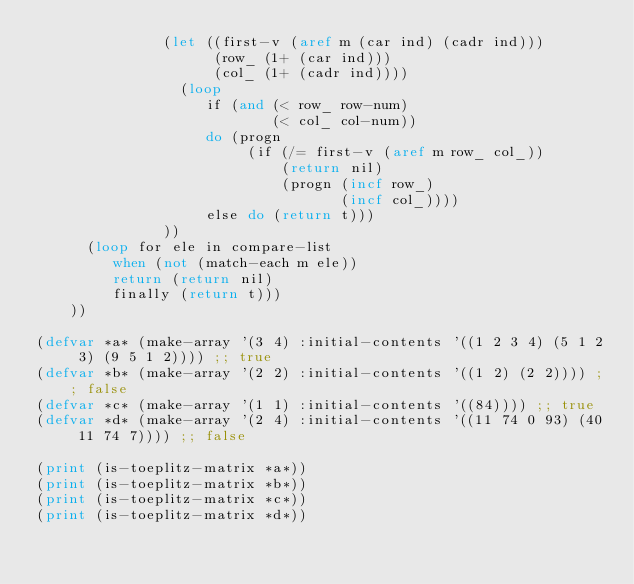<code> <loc_0><loc_0><loc_500><loc_500><_Lisp_>               (let ((first-v (aref m (car ind) (cadr ind)))
                     (row_ (1+ (car ind)))
                     (col_ (1+ (cadr ind))))
                 (loop
                    if (and (< row_ row-num)
                            (< col_ col-num))
                    do (progn 
                         (if (/= first-v (aref m row_ col_))
                             (return nil)
                             (progn (incf row_)
                                    (incf col_))))
                    else do (return t)))
               ))
      (loop for ele in compare-list
         when (not (match-each m ele))
         return (return nil)
         finally (return t)))
    ))

(defvar *a* (make-array '(3 4) :initial-contents '((1 2 3 4) (5 1 2 3) (9 5 1 2)))) ;; true
(defvar *b* (make-array '(2 2) :initial-contents '((1 2) (2 2)))) ;; false
(defvar *c* (make-array '(1 1) :initial-contents '((84)))) ;; true
(defvar *d* (make-array '(2 4) :initial-contents '((11 74 0 93) (40 11 74 7)))) ;; false

(print (is-toeplitz-matrix *a*))
(print (is-toeplitz-matrix *b*))
(print (is-toeplitz-matrix *c*))
(print (is-toeplitz-matrix *d*))
</code> 